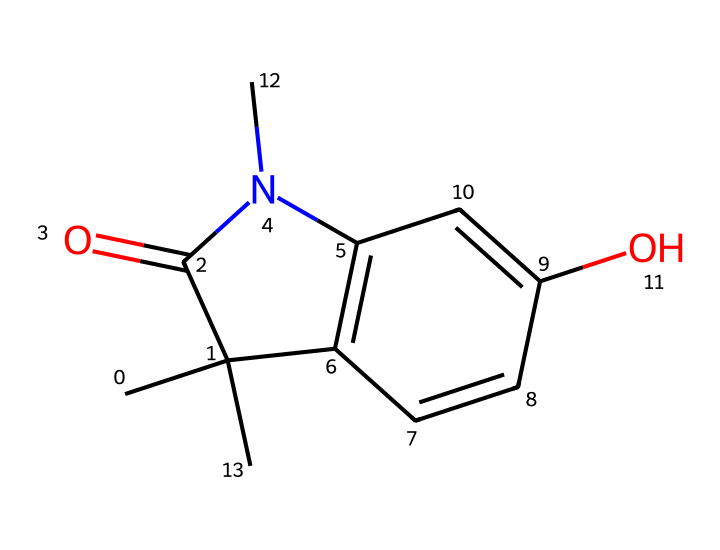What is the functional group present in this compound? The molecule contains a carbonyl group (C=O), which is typical of amides and is part of the carbamate structure. The presence of nitrogen bonded to this carbon indicates a carbamate functional group.
Answer: carbonyl How many rings are present in the chemical structure? By examining the structure, there are two distinct ring systems: one six-membered ring and another five-membered ring. Thus, the total number of rings is two.
Answer: two What type of pesticide does this molecule represent? The structure indicates that it is a carbamate pesticide due to the presence of the carbamate functional group (-OC(=O)N-), which is characteristic of this class of pesticides.
Answer: carbamate What is the total number of carbon atoms in the structure? Counting the carbon atoms in the SMILES, there are a total of 12 carbon atoms represented in the chemical structure.
Answer: twelve How does this molecule inhibit pest activity? Carbamate pesticides typically inhibit the enzyme acetylcholinesterase (AChE), which leads to an accumulation of acetylcholine in the nervous system of pests, disrupting normal signaling and causing paralysis.
Answer: AChE inhibition 